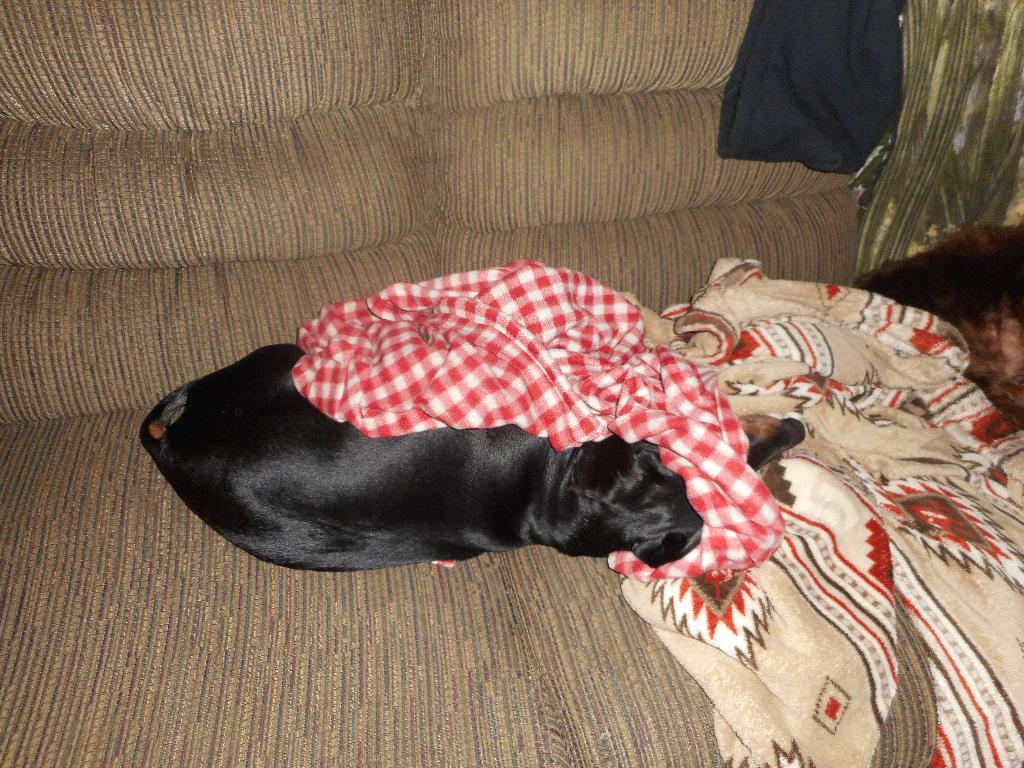What type of animal is in the image? There is a dog in the image. Where is the dog located? The dog is laying on a sofa. What else can be seen near the dog on the sofa? There are bed sheets beside the dog on the sofa. What type of cactus is the dog holding in the image? There is no cactus present in the image; the dog is laying on a sofa with bed sheets beside it. 